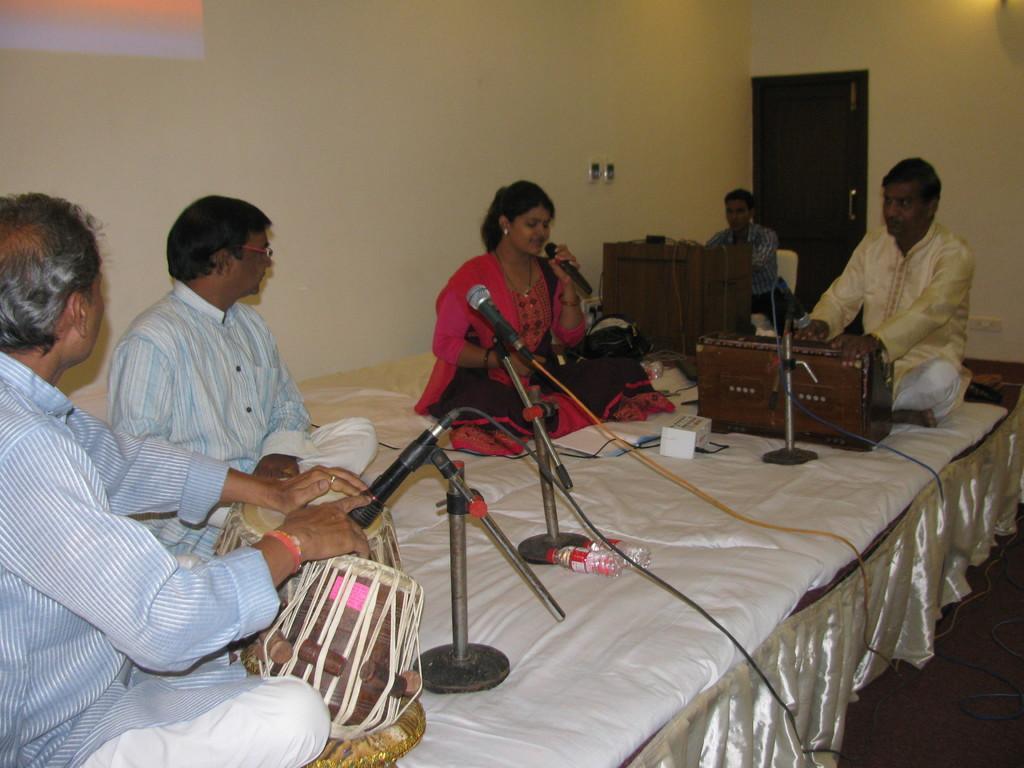Can you describe this image briefly? This picture is clicked inside the room. In the center we can see the group of persons sitting and we can see the two persons sitting and playing musical instruments and we can see the microphones attached to the metal stands and we can see a woman sitting, holding a microphone and seems to be singing. In the background we can see the wall, door, a person sitting on the chair and a wooden object and some other objects. 